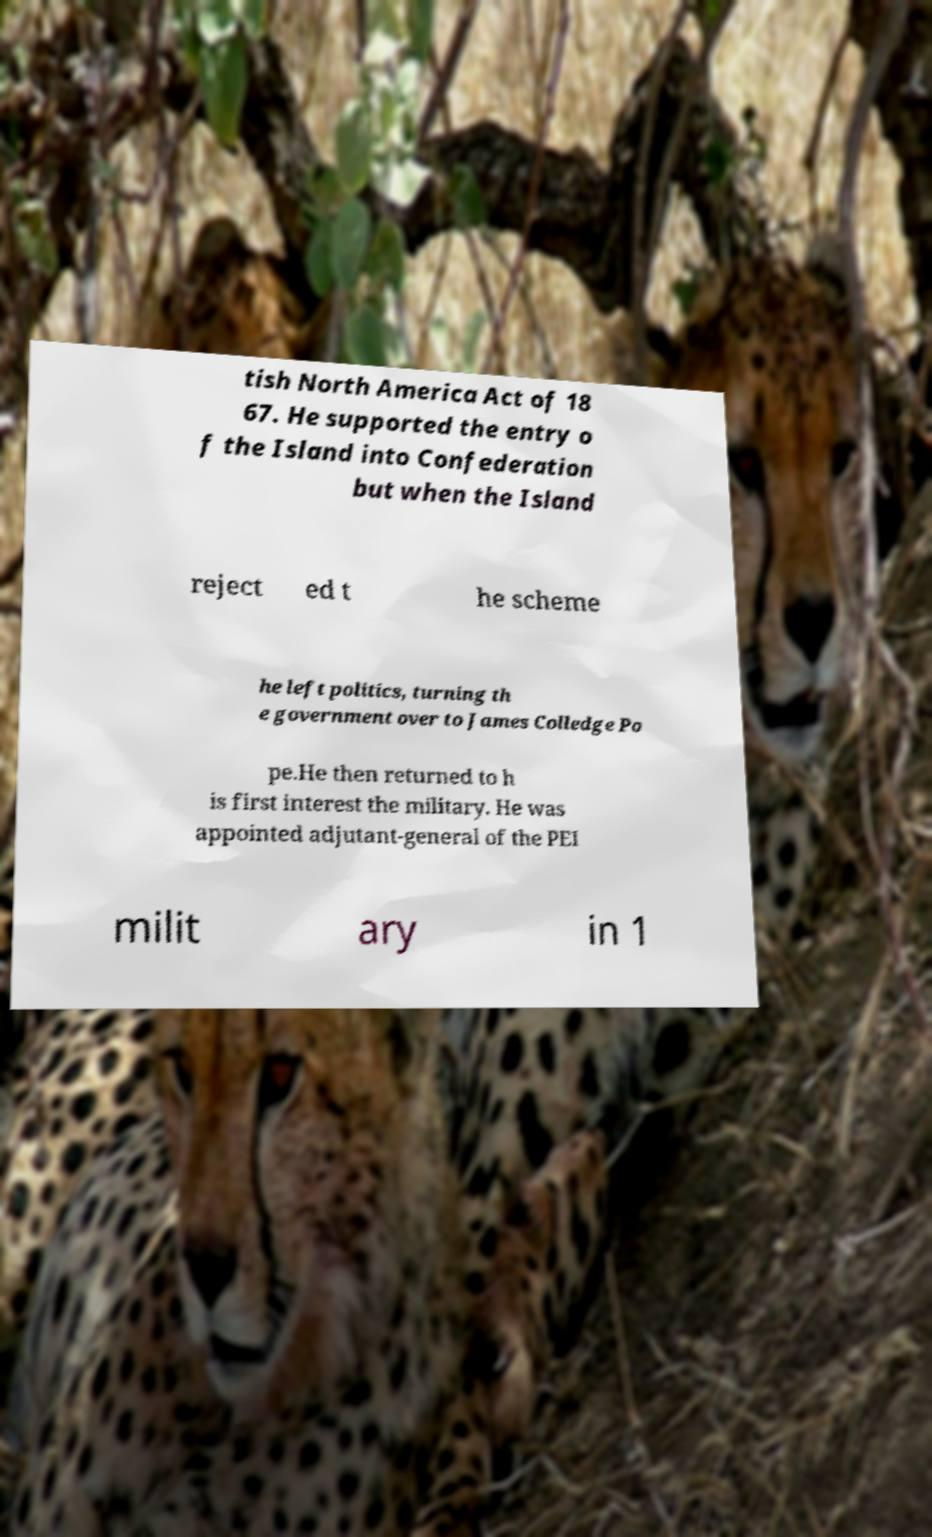I need the written content from this picture converted into text. Can you do that? tish North America Act of 18 67. He supported the entry o f the Island into Confederation but when the Island reject ed t he scheme he left politics, turning th e government over to James Colledge Po pe.He then returned to h is first interest the military. He was appointed adjutant-general of the PEI milit ary in 1 